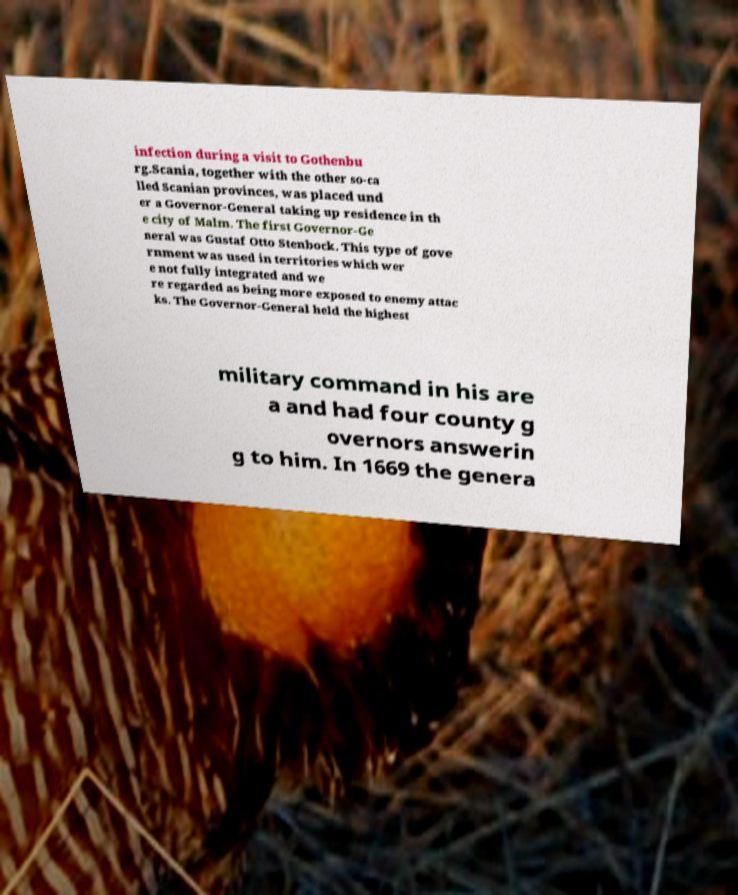I need the written content from this picture converted into text. Can you do that? infection during a visit to Gothenbu rg.Scania, together with the other so-ca lled Scanian provinces, was placed und er a Governor-General taking up residence in th e city of Malm. The first Governor-Ge neral was Gustaf Otto Stenbock. This type of gove rnment was used in territories which wer e not fully integrated and we re regarded as being more exposed to enemy attac ks. The Governor-General held the highest military command in his are a and had four county g overnors answerin g to him. In 1669 the genera 